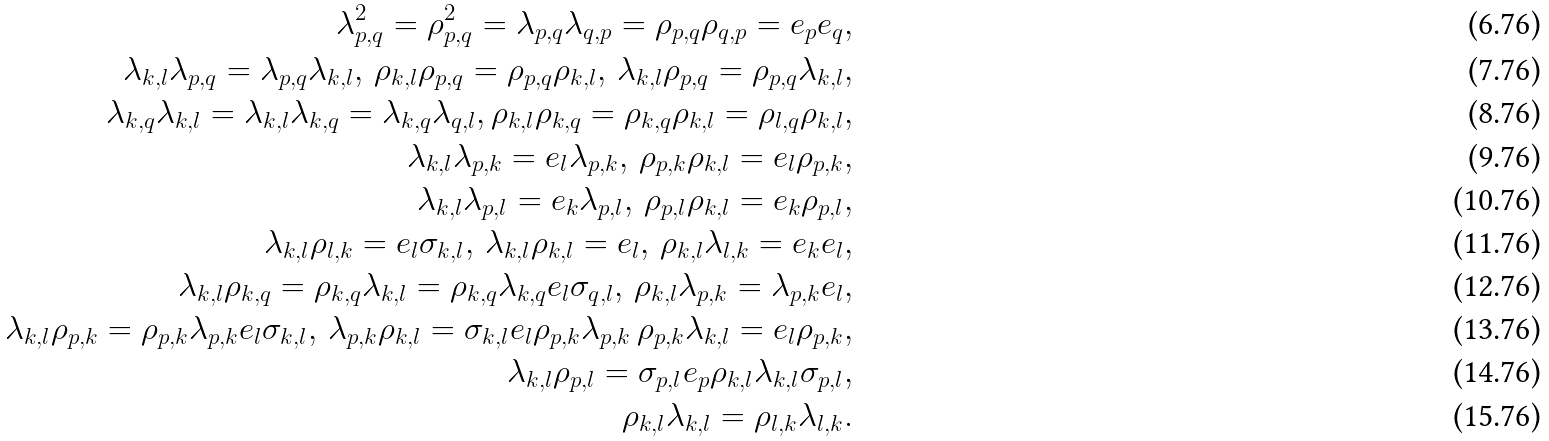Convert formula to latex. <formula><loc_0><loc_0><loc_500><loc_500>\lambda _ { p , q } ^ { 2 } = \rho _ { p , q } ^ { 2 } = \lambda _ { p , q } \lambda _ { q , p } = \rho _ { p , q } \rho _ { q , p } = e _ { p } e _ { q } , \\ \lambda _ { k , l } \lambda _ { p , q } = \lambda _ { p , q } \lambda _ { k , l } , \, \rho _ { k , l } \rho _ { p , q } = \rho _ { p , q } \rho _ { k , l } , \, \lambda _ { k , l } \rho _ { p , q } = \rho _ { p , q } \lambda _ { k , l } , \\ \lambda _ { k , q } \lambda _ { k , l } = \lambda _ { k , l } \lambda _ { k , q } = \lambda _ { k , q } \lambda _ { q , l } , \rho _ { k , l } \rho _ { k , q } = \rho _ { k , q } \rho _ { k , l } = \rho _ { l , q } \rho _ { k , l } , \\ \lambda _ { k , l } \lambda _ { p , k } = e _ { l } \lambda _ { p , k } , \, \rho _ { p , k } \rho _ { k , l } = e _ { l } \rho _ { p , k } , \\ \lambda _ { k , l } \lambda _ { p , l } = e _ { k } \lambda _ { p , l } , \, \rho _ { p , l } \rho _ { k , l } = e _ { k } \rho _ { p , l } , \\ \lambda _ { k , l } \rho _ { l , k } = e _ { l } \sigma _ { k , l } , \, \lambda _ { k , l } \rho _ { k , l } = e _ { l } , \, \rho _ { k , l } \lambda _ { l , k } = e _ { k } e _ { l } , \\ \lambda _ { k , l } \rho _ { k , q } = \rho _ { k , q } \lambda _ { k , l } = \rho _ { k , q } \lambda _ { k , q } e _ { l } \sigma _ { q , l } , \, \rho _ { k , l } \lambda _ { p , k } = \lambda _ { p , k } e _ { l } , \\ \lambda _ { k , l } \rho _ { p , k } = \rho _ { p , k } \lambda _ { p , k } e _ { l } \sigma _ { k , l } , \, \lambda _ { p , k } \rho _ { k , l } = \sigma _ { k , l } e _ { l } \rho _ { p , k } \lambda _ { p , k } \, \rho _ { p , k } \lambda _ { k , l } = e _ { l } \rho _ { p , k } , \\ \lambda _ { k , l } \rho _ { p , l } = \sigma _ { p , l } e _ { p } \rho _ { k , l } \lambda _ { k , l } \sigma _ { p , l } , \\ \rho _ { k , l } \lambda _ { k , l } = \rho _ { l , k } \lambda _ { l , k } .</formula> 